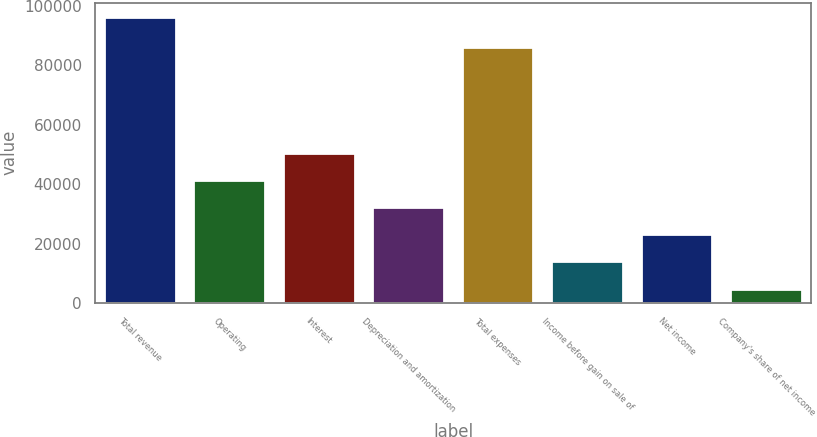Convert chart. <chart><loc_0><loc_0><loc_500><loc_500><bar_chart><fcel>Total revenue<fcel>Operating<fcel>Interest<fcel>Depreciation and amortization<fcel>Total expenses<fcel>Income before gain on sale of<fcel>Net income<fcel>Company's share of net income<nl><fcel>96189<fcel>41373<fcel>50509<fcel>32237<fcel>86177<fcel>13965<fcel>23101<fcel>4829<nl></chart> 